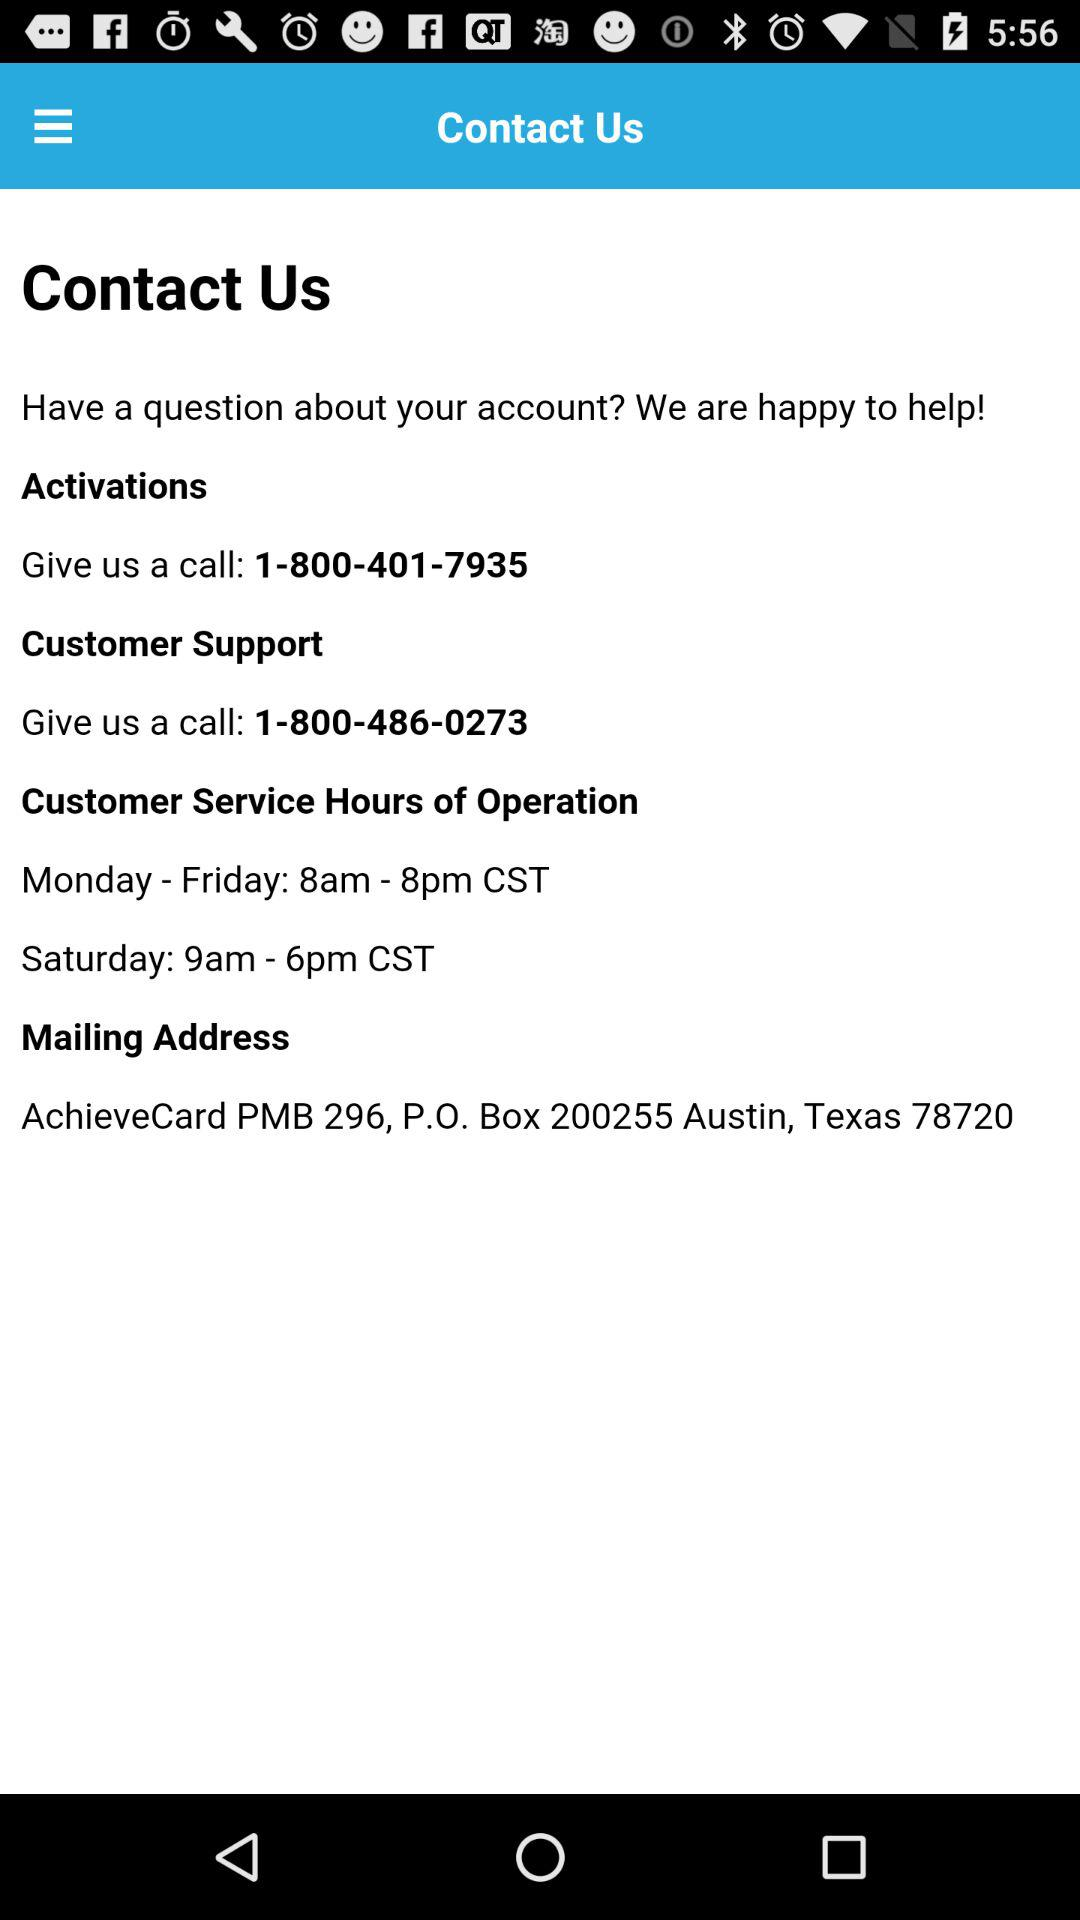What are the timings of customer service on Saturday? The times of customer service on Saturday are 9am–6pm. 